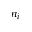<formula> <loc_0><loc_0><loc_500><loc_500>n _ { i }</formula> 